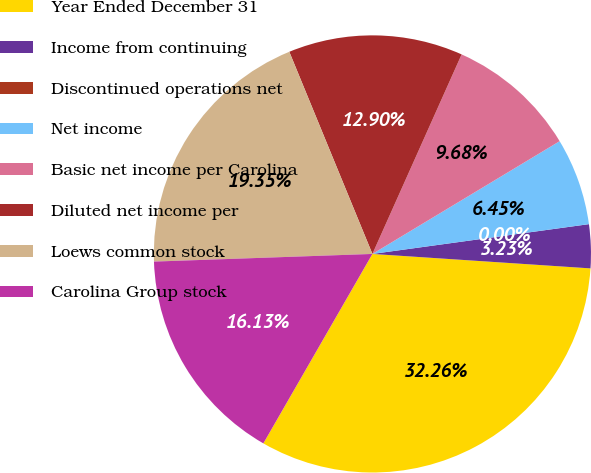Convert chart to OTSL. <chart><loc_0><loc_0><loc_500><loc_500><pie_chart><fcel>Year Ended December 31<fcel>Income from continuing<fcel>Discontinued operations net<fcel>Net income<fcel>Basic net income per Carolina<fcel>Diluted net income per<fcel>Loews common stock<fcel>Carolina Group stock<nl><fcel>32.26%<fcel>3.23%<fcel>0.0%<fcel>6.45%<fcel>9.68%<fcel>12.9%<fcel>19.35%<fcel>16.13%<nl></chart> 